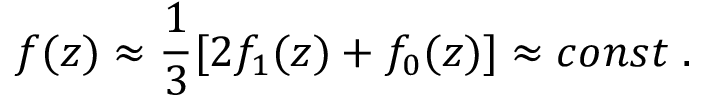Convert formula to latex. <formula><loc_0><loc_0><loc_500><loc_500>f ( z ) \approx \frac { 1 } { 3 } [ 2 f _ { 1 } ( z ) + f _ { 0 } ( z ) ] \approx c o n s t \, .</formula> 